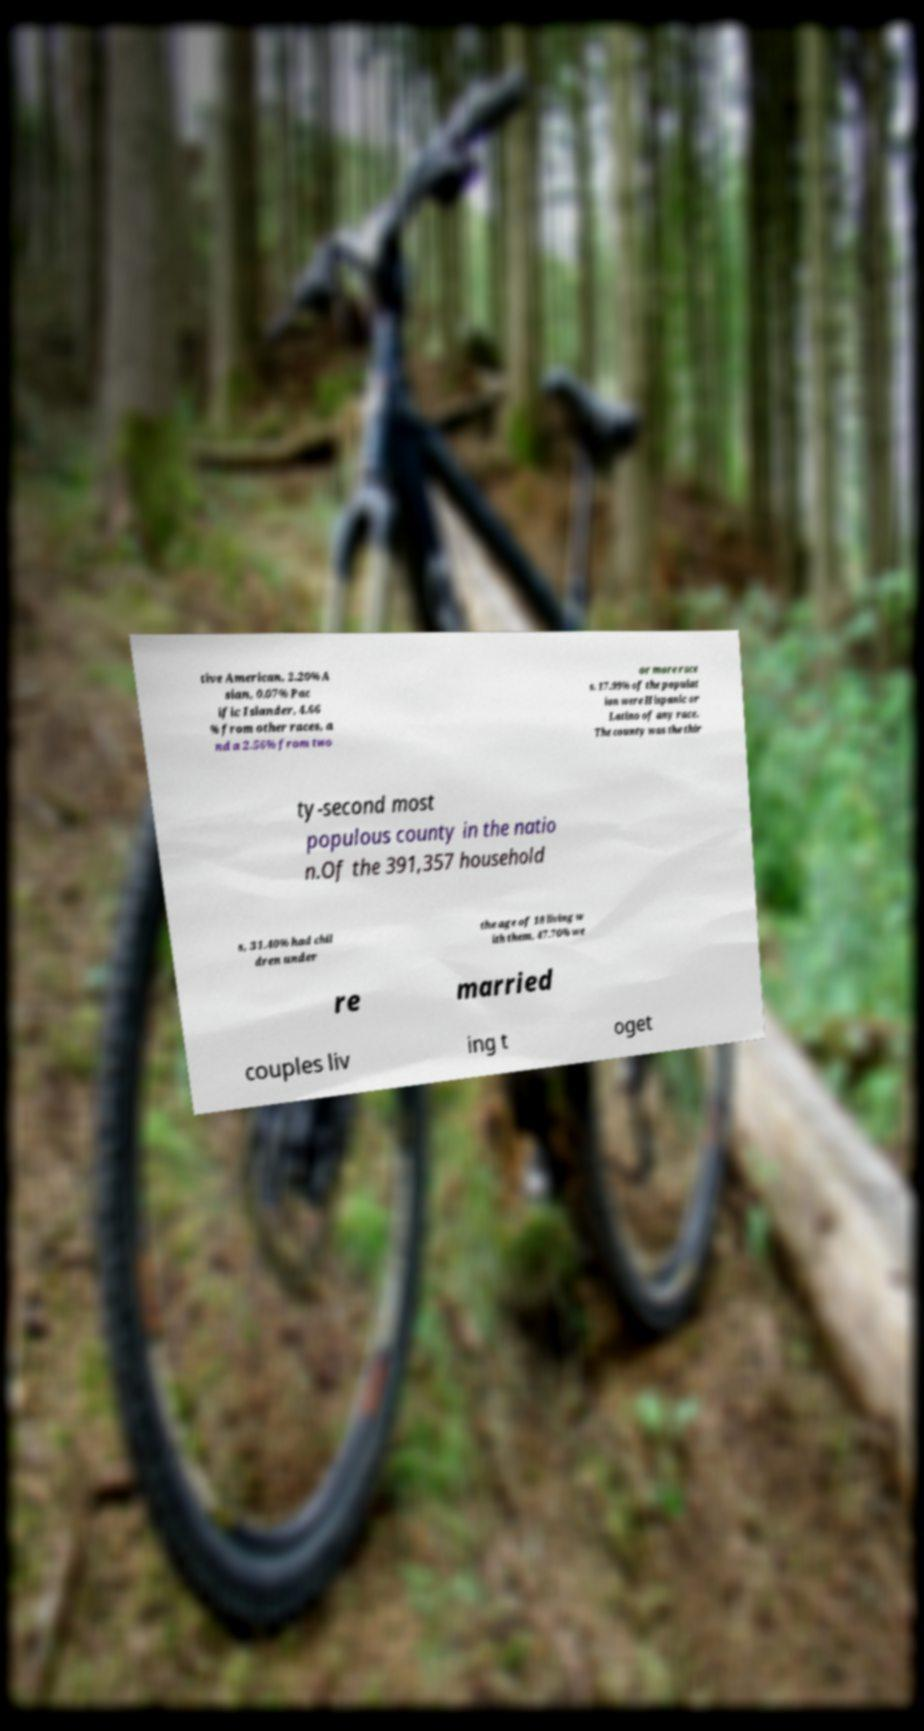Please read and relay the text visible in this image. What does it say? tive American, 2.20% A sian, 0.07% Pac ific Islander, 4.66 % from other races, a nd a 2.56% from two or more race s. 17.99% of the populat ion were Hispanic or Latino of any race. The county was the thir ty-second most populous county in the natio n.Of the 391,357 household s, 31.40% had chil dren under the age of 18 living w ith them, 47.70% we re married couples liv ing t oget 